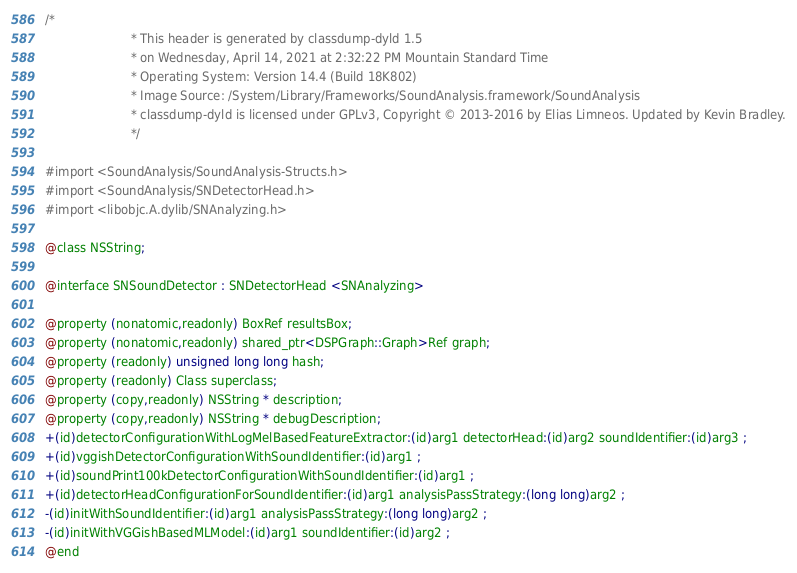Convert code to text. <code><loc_0><loc_0><loc_500><loc_500><_C_>/*
                       * This header is generated by classdump-dyld 1.5
                       * on Wednesday, April 14, 2021 at 2:32:22 PM Mountain Standard Time
                       * Operating System: Version 14.4 (Build 18K802)
                       * Image Source: /System/Library/Frameworks/SoundAnalysis.framework/SoundAnalysis
                       * classdump-dyld is licensed under GPLv3, Copyright © 2013-2016 by Elias Limneos. Updated by Kevin Bradley.
                       */

#import <SoundAnalysis/SoundAnalysis-Structs.h>
#import <SoundAnalysis/SNDetectorHead.h>
#import <libobjc.A.dylib/SNAnalyzing.h>

@class NSString;

@interface SNSoundDetector : SNDetectorHead <SNAnalyzing>

@property (nonatomic,readonly) BoxRef resultsBox; 
@property (nonatomic,readonly) shared_ptr<DSPGraph::Graph>Ref graph; 
@property (readonly) unsigned long long hash; 
@property (readonly) Class superclass; 
@property (copy,readonly) NSString * description; 
@property (copy,readonly) NSString * debugDescription; 
+(id)detectorConfigurationWithLogMelBasedFeatureExtractor:(id)arg1 detectorHead:(id)arg2 soundIdentifier:(id)arg3 ;
+(id)vggishDetectorConfigurationWithSoundIdentifier:(id)arg1 ;
+(id)soundPrint100kDetectorConfigurationWithSoundIdentifier:(id)arg1 ;
+(id)detectorHeadConfigurationForSoundIdentifier:(id)arg1 analysisPassStrategy:(long long)arg2 ;
-(id)initWithSoundIdentifier:(id)arg1 analysisPassStrategy:(long long)arg2 ;
-(id)initWithVGGishBasedMLModel:(id)arg1 soundIdentifier:(id)arg2 ;
@end

</code> 